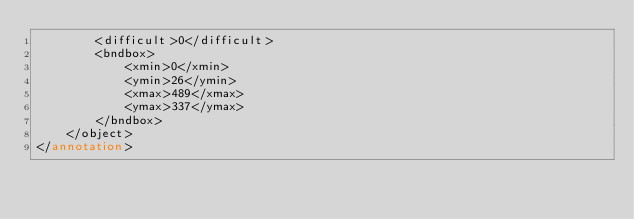Convert code to text. <code><loc_0><loc_0><loc_500><loc_500><_XML_>		<difficult>0</difficult>
		<bndbox>
			<xmin>0</xmin>
			<ymin>26</ymin>
			<xmax>489</xmax>
			<ymax>337</ymax>
		</bndbox>
	</object>
</annotation></code> 